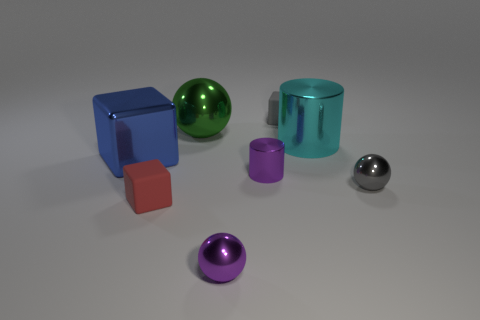Add 2 green metal things. How many objects exist? 10 Subtract all spheres. How many objects are left? 5 Subtract all red things. Subtract all big cyan metal cylinders. How many objects are left? 6 Add 4 big metallic blocks. How many big metallic blocks are left? 5 Add 4 gray metal spheres. How many gray metal spheres exist? 5 Subtract 0 brown blocks. How many objects are left? 8 